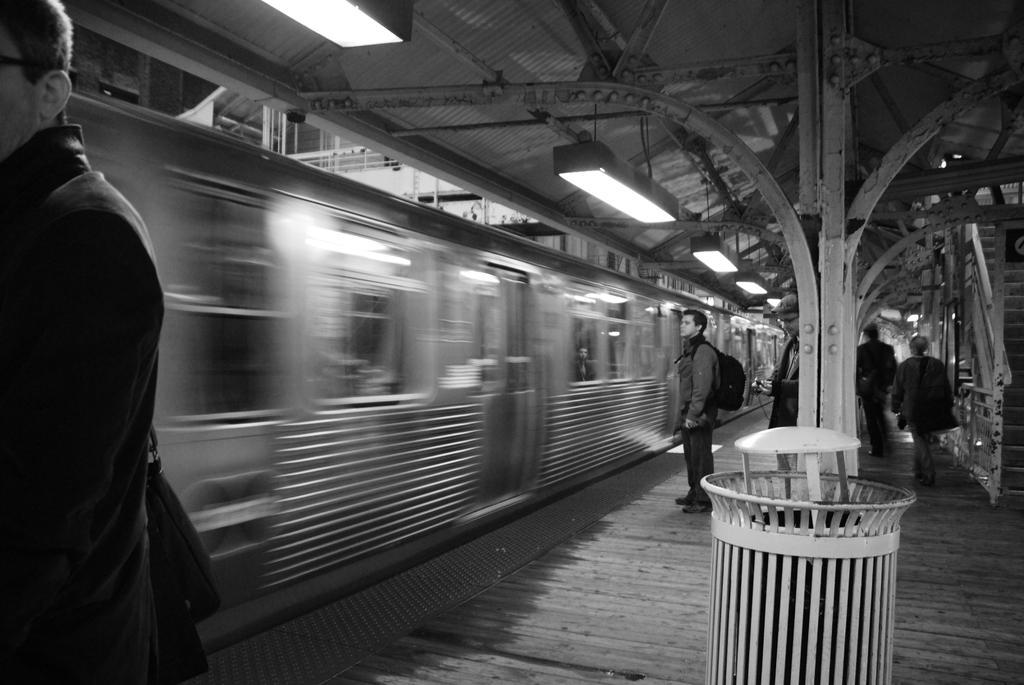Describe this image in one or two sentences. In this image I can see the black and white picture in which I can see the platform, a dustbin, few persons standing on the platform, a metal pillar, few stairs, the railing, few lights and a train. I can see a bridge on the top of the train. 